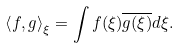Convert formula to latex. <formula><loc_0><loc_0><loc_500><loc_500>\left < f , g \right > _ { \xi } = \int f ( \xi ) \overline { g ( \xi ) } d \xi .</formula> 